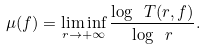Convert formula to latex. <formula><loc_0><loc_0><loc_500><loc_500>\mu ( f ) = \liminf _ { r \rightarrow + \infty } \frac { \log \ T ( r , f ) } { \log \ r } .</formula> 